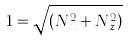<formula> <loc_0><loc_0><loc_500><loc_500>1 = \sqrt { ( N _ { x } ^ { 2 } + N _ { z } ^ { 2 } ) }</formula> 